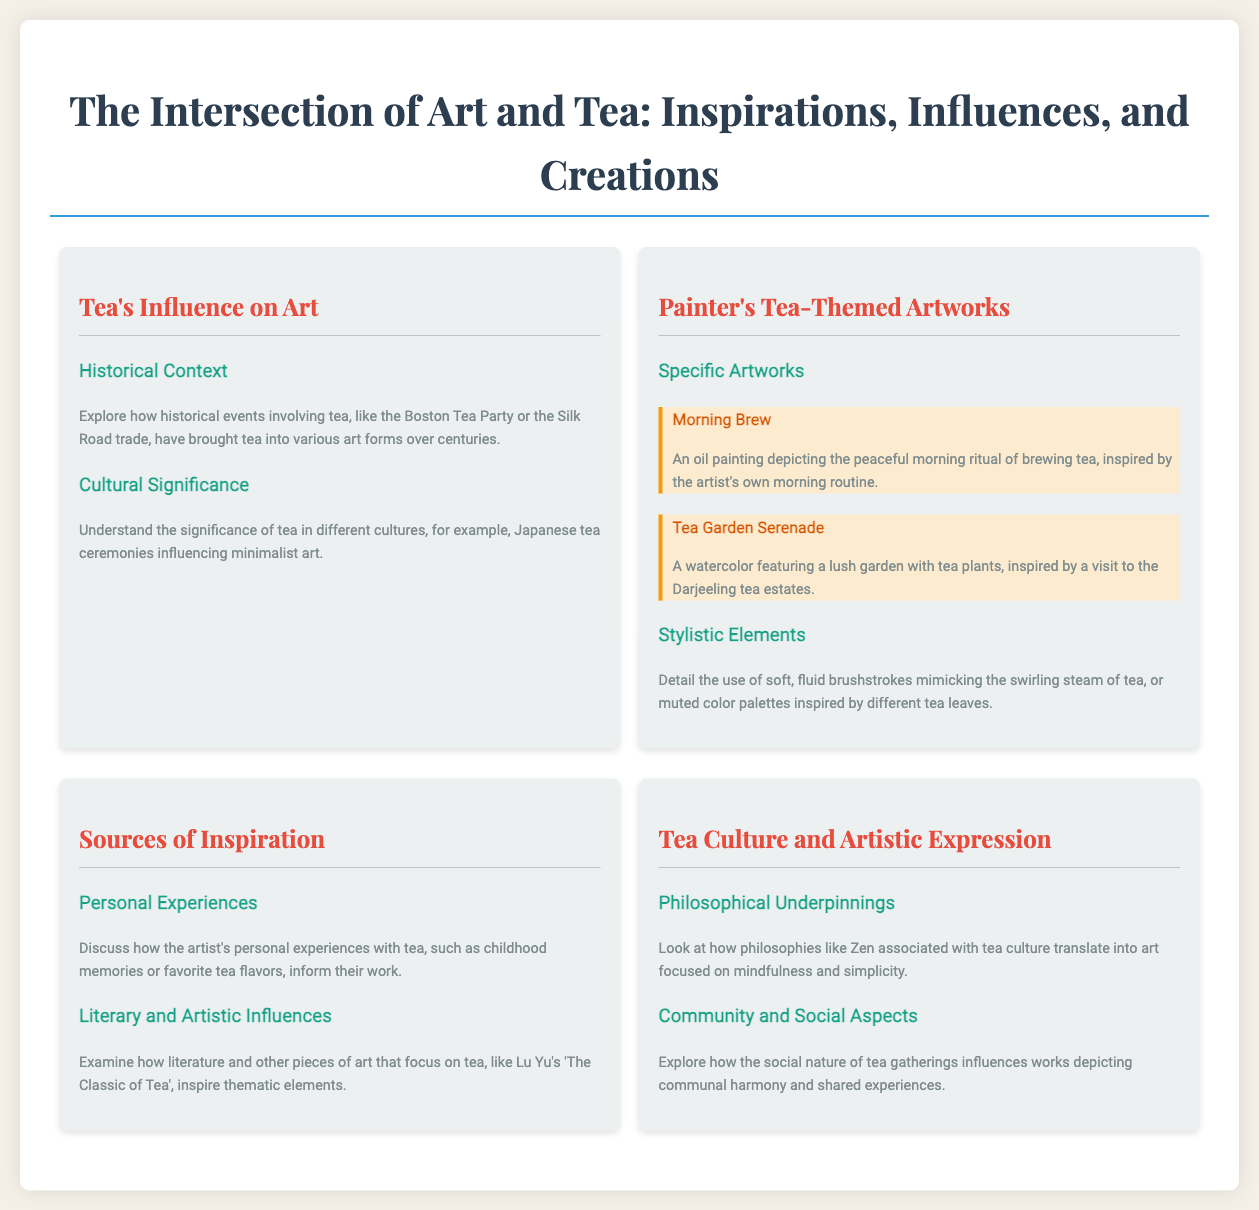what is the title of the painter's artwork depicting a morning ritual? The title 'Morning Brew' describes the painting that captures the peaceful morning ritual of brewing tea.
Answer: Morning Brew what artistic technique is noted in the painter's tea-themed artworks? The document mentions the use of soft, fluid brushstrokes that mimic the swirling steam of tea.
Answer: Soft, fluid brushstrokes which historical event involving tea is referenced in the document? The Boston Tea Party is highlighted as one of the historical events bringing tea into various art forms.
Answer: Boston Tea Party how many specific artworks are mentioned in the painter's collection? The document lists two specific artworks related to tea, 'Morning Brew' and 'Tea Garden Serenade'.
Answer: Two what cultural practice is said to influence minimalist art? Japanese tea ceremonies are noted for their influence on minimalist art.
Answer: Japanese tea ceremonies what type of influences are examined under 'Sources of Inspiration'? The section discusses literature and other pieces of art that focus on tea as influences.
Answer: Literary and Artistic Influences what philosophical concept is associated with tea culture in the document? The document connects Zen philosophy with tea culture, emphasizing mindfulness and simplicity in art.
Answer: Zen what is the format of the infographic presented in the document? The structure is hierarchical with sections and subsections detailing specific themes related to art and tea.
Answer: Hierarchical 